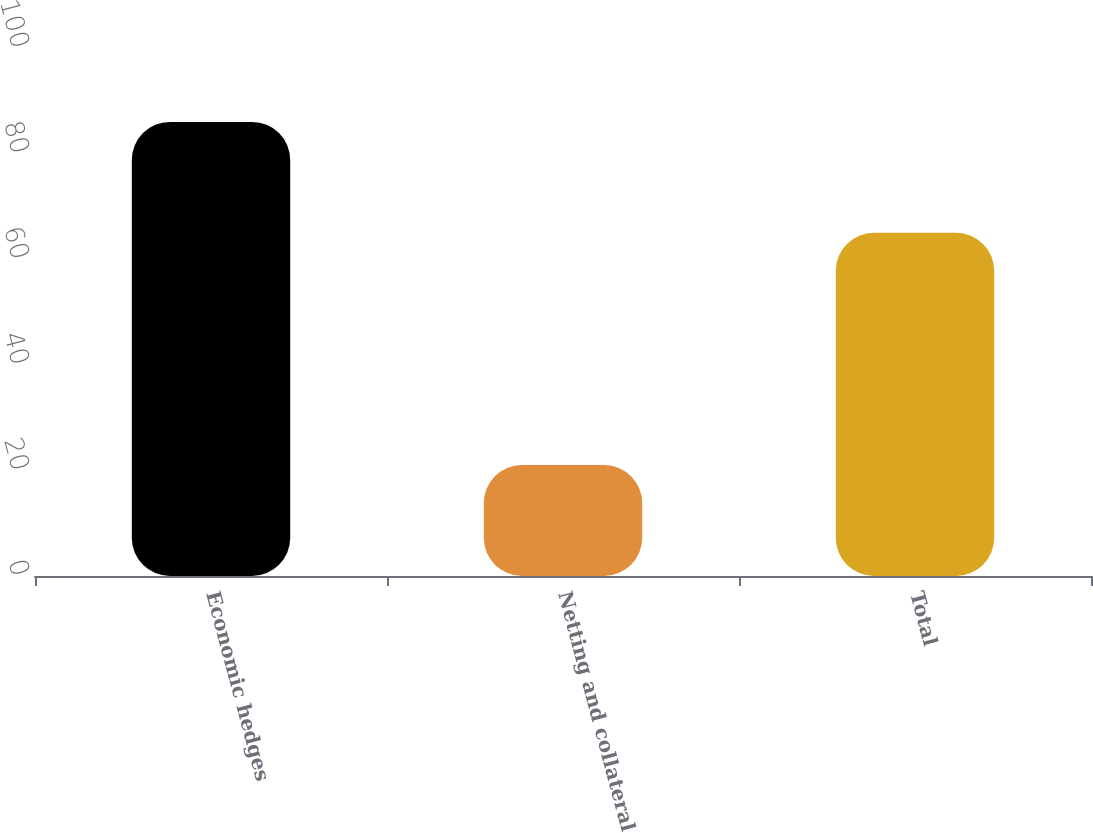Convert chart to OTSL. <chart><loc_0><loc_0><loc_500><loc_500><bar_chart><fcel>Economic hedges<fcel>Netting and collateral<fcel>Total<nl><fcel>86<fcel>21<fcel>65<nl></chart> 